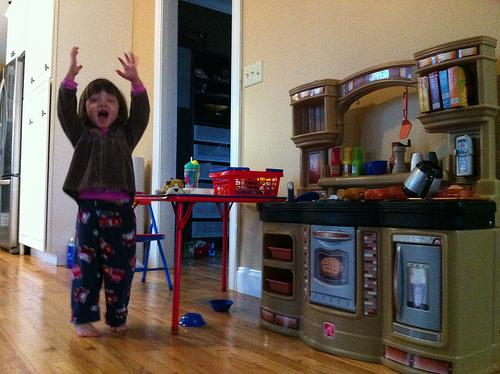Describe the appearance of the floor and the wall in the image. The floor is made of shining light wood and is brown, while the wall is off white in color. What objects are part of the toy kitchen playset and their characteristics? The pretend kitchen playset includes a toy phone, cereal boxes, toy bottles of condiments, a toy electric kettle, an orange spatula, and doors to a toy oven and microwave. How many blue bowls can be seen in the image and where are they located? There are four blue bowls in total, with two on the ground and a pair of small ones upside down. Can you identify a toy and its color that's placed on top of the table? A red bin and a bottle are on top of the table. Explain the key features of the light switch. The light switch is white, located above the table, and has three switches. What is the color and location of the orange spatula? The orange spatula is hanging from a hook in the toy kitchen area. Identify two types of toy containers and their colors. A red plastic shopping basket with black handles and a red and blue plastic basket are in the image. Mention the objects located on the ground and their colors. There are two blue bowls upside down, a child's bare feet and a blue folding chair with a red cushion on the ground. What color is the toddler's shirt and what are they doing in the image? The toddler has a brown shirt over pink and is reaching up, looking very excited. Describe the person's outfit in terms of colors and design. The person is wearing a gray top with long sleeves and blue pants which have designs on them. Name all the objects placed on top of the toy kitchen. Cereal box, toy phone, toy bottles of condiments, toy electric kettle What is the toddler wearing on their upper body? Gray top with long sleeves What is the color scheme of the red plastic shopping basket? Red with black handles What type of cup can be seen in the image? Child's sippy cup Identify the color of the folding chair and its cushion. Blue folding chair with a red cushion What color is the kitchen playset, and what is it made of? Olive green, toy Could you please point out where the stack of blue plates is on the table? No stack of blue plates is described in the provided image information. The interrogative sentence creates a sense of uncertainty and curiosity about locating the non-existent object. Does this room have a colorful rug on the wooden floor? No, it's not mentioned in the image. Count the number of switches on the light switch. Three It seems like there's a purple umbrella leaning against the wall near the refrigerator. A purple umbrella is not described in the image information provided. The declarative sentence falsely states its existence, causing confusion for someone trying to locate the object. Which of the following objects is on top of the table: a) bottle, b) picture of pie, c) blue bowl? a) bottle Identify the type of pants the person is wearing and any designs on them. Blue pants with designs Create a multi-modal description of the blue bowl on the ground. Two blue plastic toy bowls upside down on the floor Describe the toy phone found in the scene. Toy phone on toy kitchen There is a beautiful painting of a sunset hanging on the off-white wall. The image information does not mention any painting of a sunset. The declarative sentence misleadingly suggests the presence of a painting in the room, which could cause confusion. What event can be observed in the image involving a sticker? Sticker of a pie baking in the oven Explain the position of the cereal boxes in the image. Toy cereal boxes on toy kitchen Determine the material and color of the floor. Light wood floor, brown color Describe the emotions of the toddler. Very excited Describe the toy electric kettle in the image. Toy electric kettle on playset In the image, what is the toddler reaching for? The toddler is reaching up Can you identify an object hanging from a hook in the image? Orange spatula What is happening in the scene with the toddler and the various toys? A small toddler girl is excitedly playing with a toy kitchen set, brightly-colored toy bowls and baskets, and reaching for a pretend oven. What color is the light switch above the table? White 